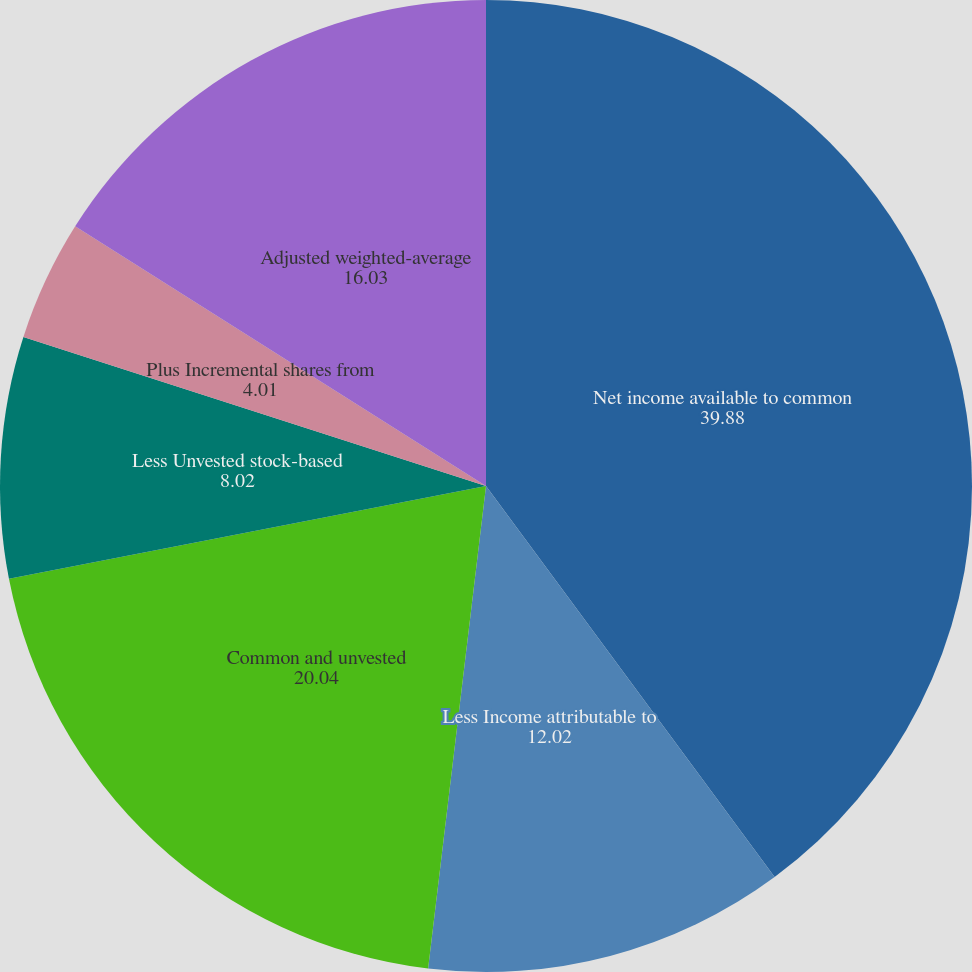Convert chart to OTSL. <chart><loc_0><loc_0><loc_500><loc_500><pie_chart><fcel>Net income available to common<fcel>Less Income attributable to<fcel>Common and unvested<fcel>Less Unvested stock-based<fcel>Plus Incremental shares from<fcel>Adjusted weighted-average<fcel>Diluted earnings per common<nl><fcel>39.88%<fcel>12.02%<fcel>20.04%<fcel>8.02%<fcel>4.01%<fcel>16.03%<fcel>0.0%<nl></chart> 